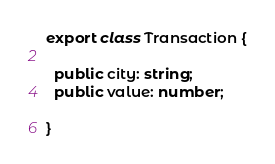<code> <loc_0><loc_0><loc_500><loc_500><_TypeScript_>export class Transaction {

  public city: string;
  public value: number;

}</code> 